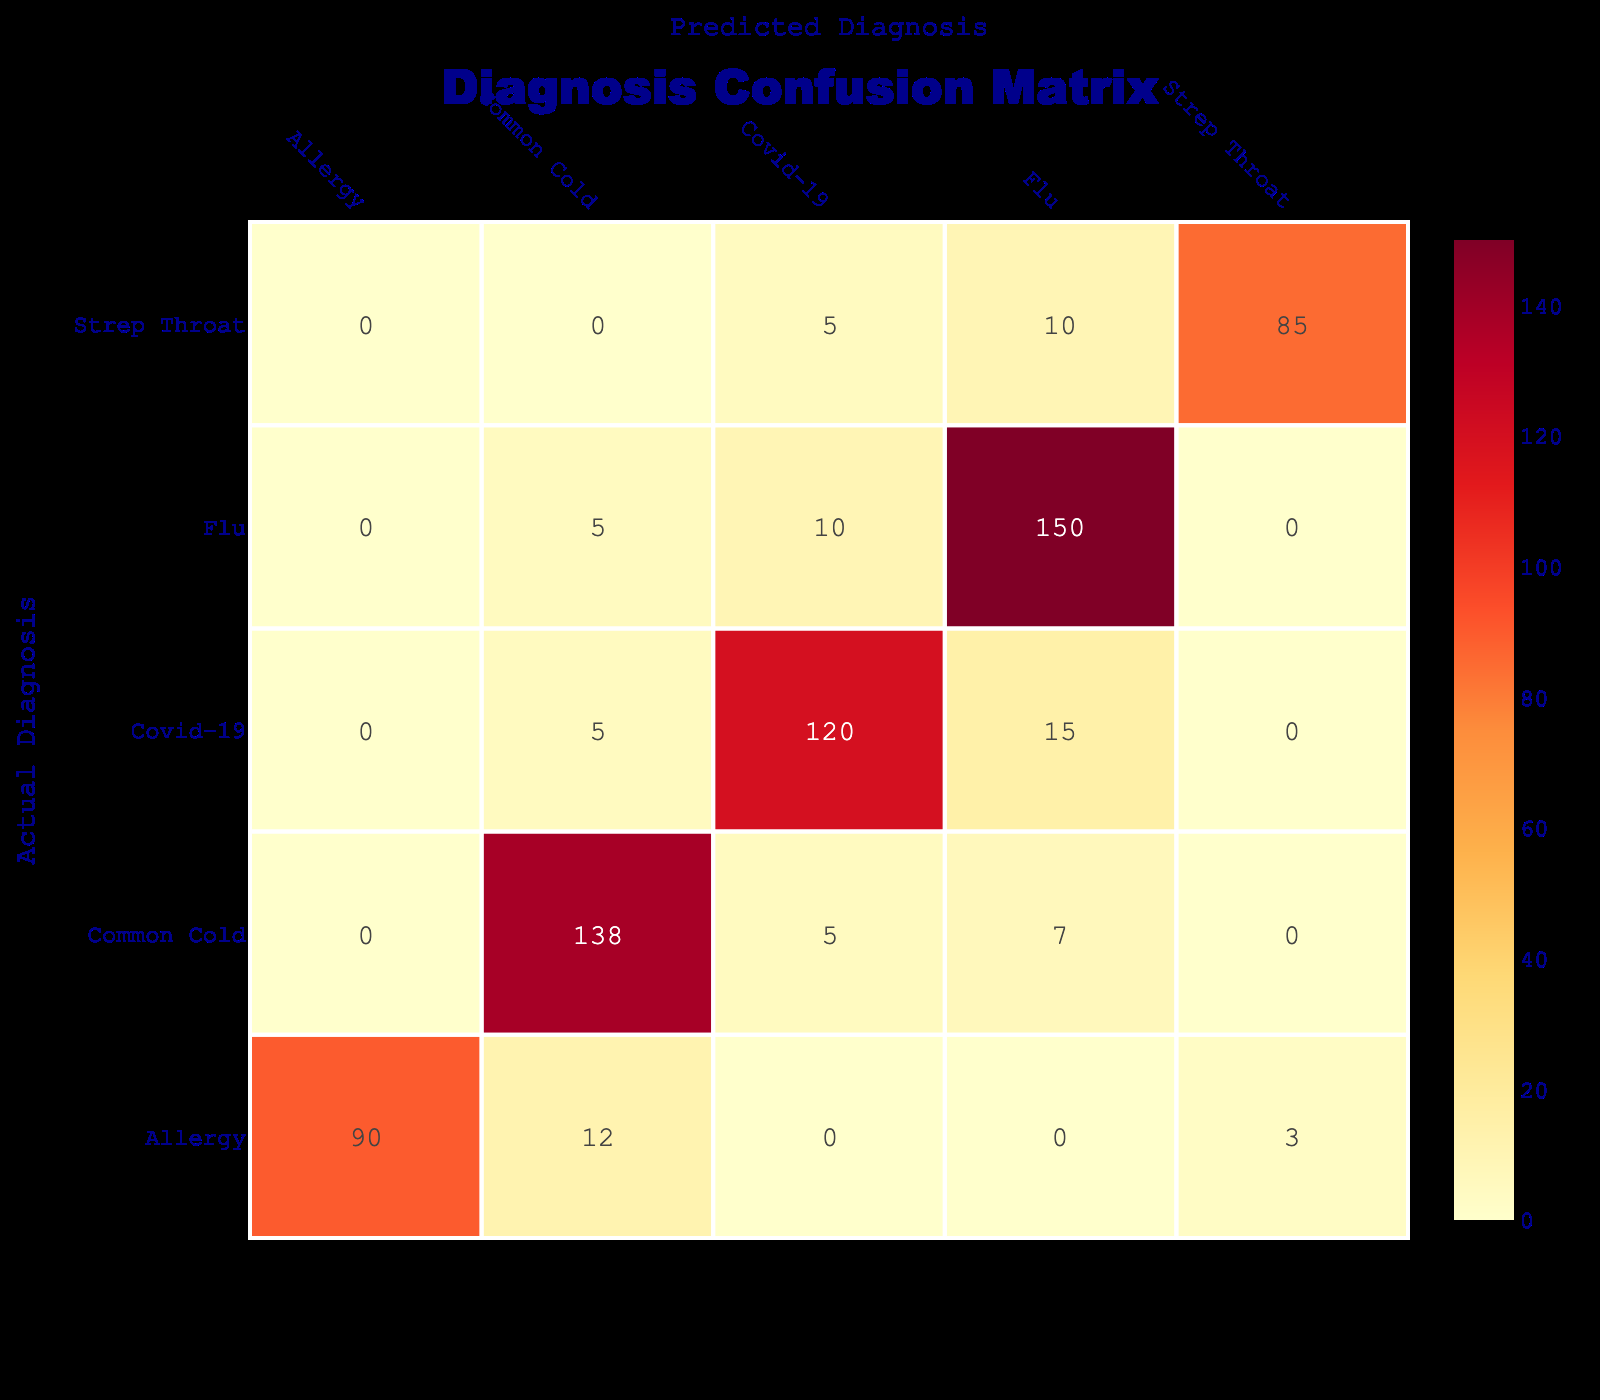What is the count of actual diagnoses for Strep Throat predicted as the same? Looking at the table, we can see that the count of instances where Strep Throat was both the actual and predicted diagnosis is 85.
Answer: 85 What is the total number of Flu diagnoses predicted incorrectly? For Flu, the predicted counts of Covid-19 (10) and Common Cold (5) can be added together for the total of incorrect predictions: 10 + 5 = 15.
Answer: 15 How many diagnoses were predicted as Common Cold? To find this, we look at the counts for Common Cold in the Predicted Diagnosis column. Adding the values gives: Strep Throat (12) + Allergy (12) + Common Cold (138) + Flu (7) + Covid-19 (5) = 174.
Answer: 174 Is it true that the Covid-19 diagnosis was incorrectly predicted as Flu more than it was correctly predicted? The count of Covid-19 diagnosed correctly was 120, while it was predicted as Flu 15 times. Since 120 is greater than 15, the statement is false.
Answer: No What is the difference in the correct predictions between Allergy and Strep Throat? The correct prediction for Allergy is 90 and for Strep Throat is 85. The difference is 90 - 85 = 5.
Answer: 5 What percentage of actual Common Cold cases were predicted as the same? The actual count for Common Cold is 138, and the predicted cases as Common Cold are also 138. Thus, (138/138) * 100 = 100%.
Answer: 100% How many total misclassifications were made in the diagnosis of Covid-19? Covid-19 was misclassified when it was predicted as Flu (15) and Common Cold (5), so adding these gives 15 + 5 = 20.
Answer: 20 Which disease has the highest count of correct predictions? The counts can be compared for correct predictions: Flu (150), Covid-19 (120), Common Cold (138), Strep Throat (85), and Allergy (90). The highest is Flu with 150.
Answer: Flu How many total diagnoses are represented in the table? The total can be found by summing all the counts across all actual diagnoses: 150 + 10 + 5 + 120 + 15 + 5 + 138 + 7 + 5 + 85 + 10 + 5 + 90 + 12 + 3 = 540.
Answer: 540 